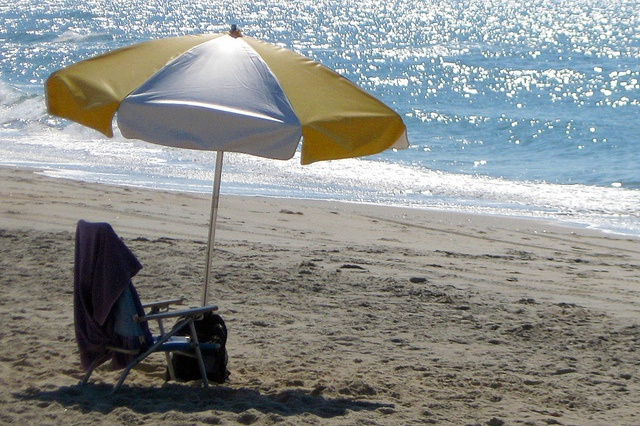Describe the objects in this image and their specific colors. I can see umbrella in lightgray, gray, tan, olive, and darkgray tones, chair in lightgray, black, gray, and darkgray tones, and backpack in lightgray, black, and gray tones in this image. 